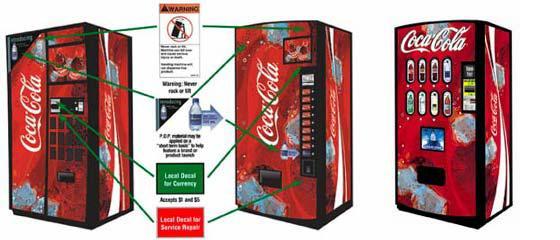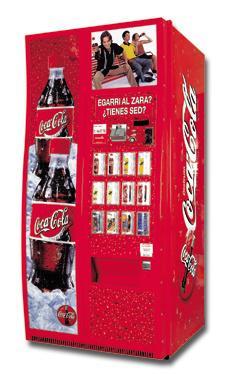The first image is the image on the left, the second image is the image on the right. Evaluate the accuracy of this statement regarding the images: "In one of the images, there are three machines.". Is it true? Answer yes or no. Yes. 